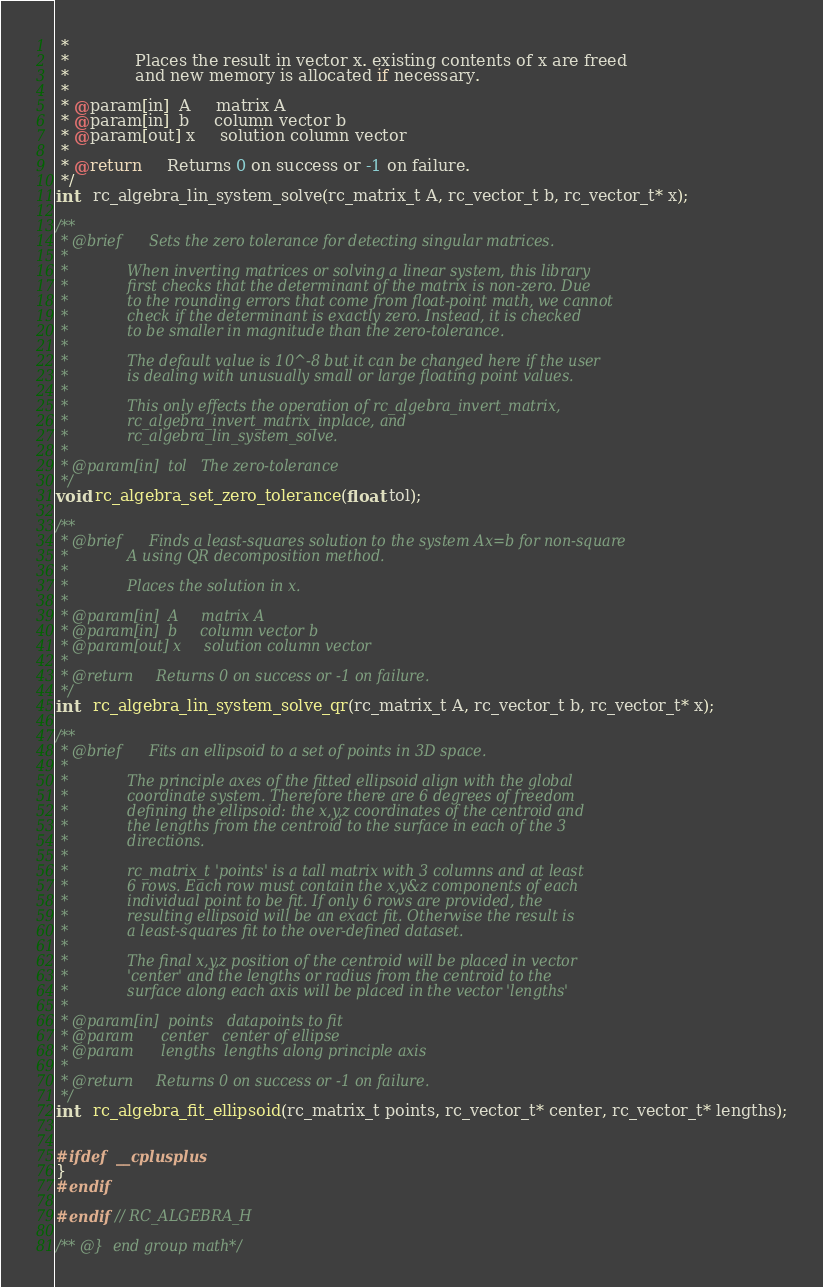<code> <loc_0><loc_0><loc_500><loc_500><_C_> *
 *             Places the result in vector x. existing contents of x are freed
 *             and new memory is allocated if necessary.
 *
 * @param[in]  A     matrix A
 * @param[in]  b     column vector b
 * @param[out] x     solution column vector
 *
 * @return     Returns 0 on success or -1 on failure.
 */
int   rc_algebra_lin_system_solve(rc_matrix_t A, rc_vector_t b, rc_vector_t* x);

/**
 * @brief      Sets the zero tolerance for detecting singular matrices.
 *
 *             When inverting matrices or solving a linear system, this library
 *             first checks that the determinant of the matrix is non-zero. Due
 *             to the rounding errors that come from float-point math, we cannot
 *             check if the determinant is exactly zero. Instead, it is checked
 *             to be smaller in magnitude than the zero-tolerance.
 *
 *             The default value is 10^-8 but it can be changed here if the user
 *             is dealing with unusually small or large floating point values.
 *
 *             This only effects the operation of rc_algebra_invert_matrix,
 *             rc_algebra_invert_matrix_inplace, and
 *             rc_algebra_lin_system_solve.
 *
 * @param[in]  tol   The zero-tolerance
 */
void rc_algebra_set_zero_tolerance(float tol);

/**
 * @brief      Finds a least-squares solution to the system Ax=b for non-square
 *             A using QR decomposition method.
 *
 *             Places the solution in x.
 *
 * @param[in]  A     matrix A
 * @param[in]  b     column vector b
 * @param[out] x     solution column vector
 *
 * @return     Returns 0 on success or -1 on failure.
 */
int   rc_algebra_lin_system_solve_qr(rc_matrix_t A, rc_vector_t b, rc_vector_t* x);

/**
 * @brief      Fits an ellipsoid to a set of points in 3D space.
 *
 *             The principle axes of the fitted ellipsoid align with the global
 *             coordinate system. Therefore there are 6 degrees of freedom
 *             defining the ellipsoid: the x,y,z coordinates of the centroid and
 *             the lengths from the centroid to the surface in each of the 3
 *             directions.
 *
 *             rc_matrix_t 'points' is a tall matrix with 3 columns and at least
 *             6 rows. Each row must contain the x,y&z components of each
 *             individual point to be fit. If only 6 rows are provided, the
 *             resulting ellipsoid will be an exact fit. Otherwise the result is
 *             a least-squares fit to the over-defined dataset.
 *
 *             The final x,y,z position of the centroid will be placed in vector
 *             'center' and the lengths or radius from the centroid to the
 *             surface along each axis will be placed in the vector 'lengths'
 *
 * @param[in]  points   datapoints to fit
 * @param      center   center of ellipse
 * @param      lengths  lengths along principle axis
 *
 * @return     Returns 0 on success or -1 on failure.
 */
int   rc_algebra_fit_ellipsoid(rc_matrix_t points, rc_vector_t* center, rc_vector_t* lengths);


#ifdef  __cplusplus
}
#endif

#endif // RC_ALGEBRA_H

/** @}  end group math*/</code> 